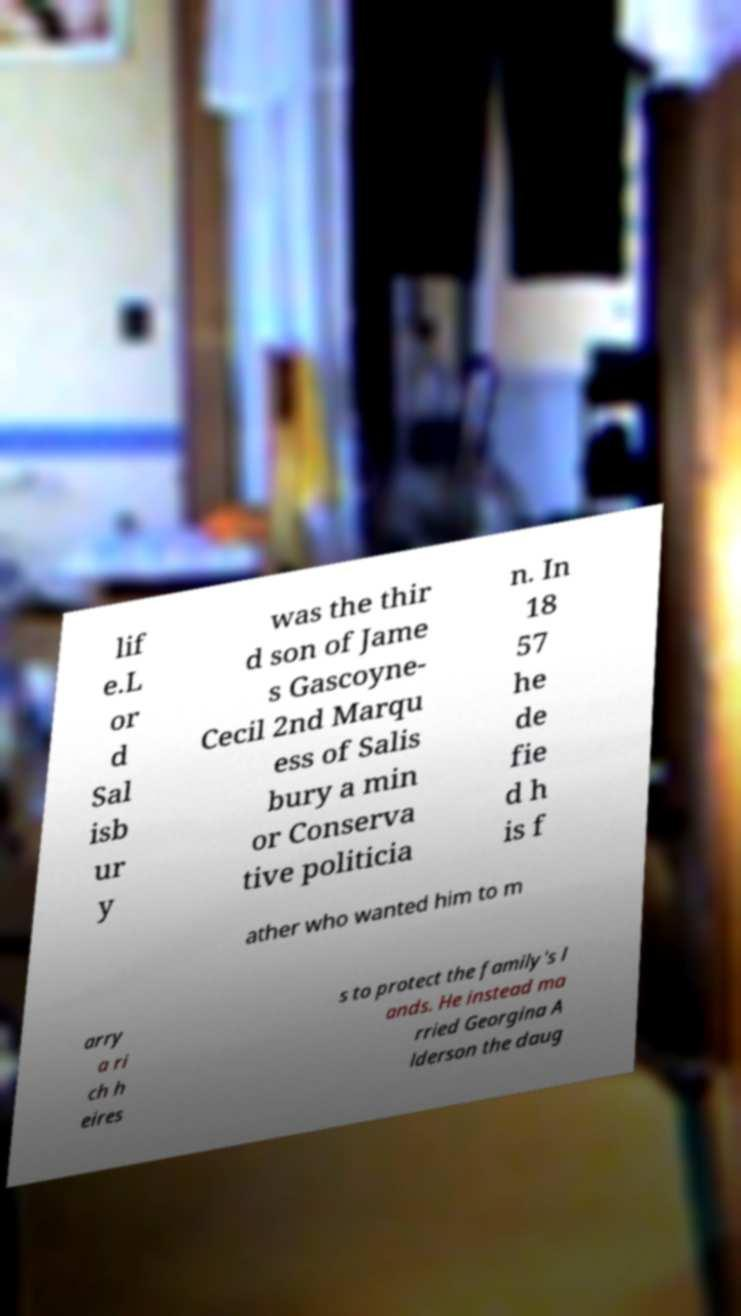Could you extract and type out the text from this image? lif e.L or d Sal isb ur y was the thir d son of Jame s Gascoyne- Cecil 2nd Marqu ess of Salis bury a min or Conserva tive politicia n. In 18 57 he de fie d h is f ather who wanted him to m arry a ri ch h eires s to protect the family's l ands. He instead ma rried Georgina A lderson the daug 